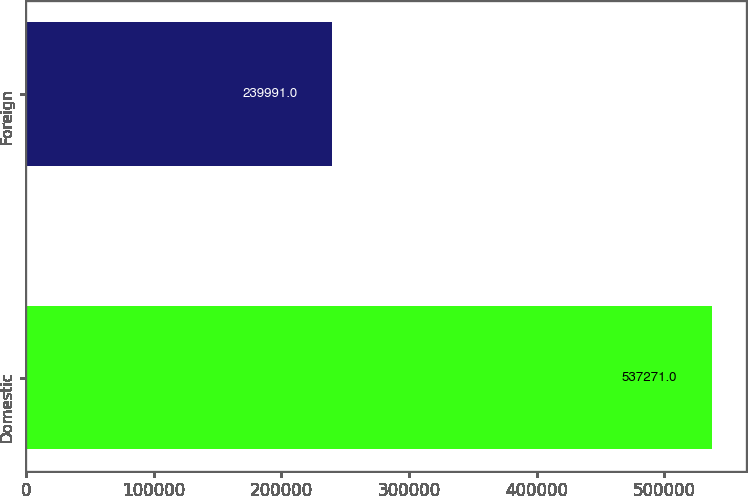Convert chart to OTSL. <chart><loc_0><loc_0><loc_500><loc_500><bar_chart><fcel>Domestic<fcel>Foreign<nl><fcel>537271<fcel>239991<nl></chart> 